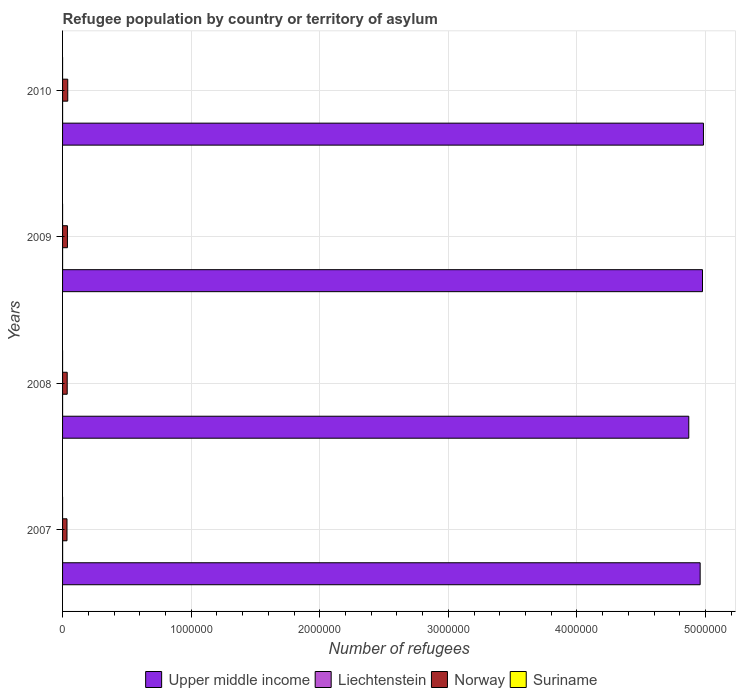How many different coloured bars are there?
Offer a very short reply. 4. What is the label of the 4th group of bars from the top?
Offer a terse response. 2007. What is the number of refugees in Liechtenstein in 2007?
Provide a succinct answer. 283. Across all years, what is the maximum number of refugees in Upper middle income?
Offer a very short reply. 4.98e+06. Across all years, what is the minimum number of refugees in Norway?
Your answer should be very brief. 3.45e+04. In which year was the number of refugees in Norway minimum?
Your answer should be very brief. 2007. What is the total number of refugees in Norway in the graph?
Provide a succinct answer. 1.49e+05. What is the difference between the number of refugees in Norway in 2007 and that in 2008?
Provide a short and direct response. -1579. What is the difference between the number of refugees in Upper middle income in 2008 and the number of refugees in Norway in 2007?
Keep it short and to the point. 4.84e+06. In the year 2007, what is the difference between the number of refugees in Norway and number of refugees in Liechtenstein?
Keep it short and to the point. 3.42e+04. What is the ratio of the number of refugees in Liechtenstein in 2009 to that in 2010?
Ensure brevity in your answer.  0.99. Is the number of refugees in Liechtenstein in 2007 less than that in 2009?
Make the answer very short. No. Is the difference between the number of refugees in Norway in 2008 and 2009 greater than the difference between the number of refugees in Liechtenstein in 2008 and 2009?
Provide a short and direct response. No. What is the difference between the highest and the second highest number of refugees in Upper middle income?
Give a very brief answer. 7314. What is the difference between the highest and the lowest number of refugees in Liechtenstein?
Your answer should be very brief. 194. Is the sum of the number of refugees in Suriname in 2007 and 2010 greater than the maximum number of refugees in Norway across all years?
Offer a very short reply. No. What does the 4th bar from the top in 2010 represents?
Provide a succinct answer. Upper middle income. Is it the case that in every year, the sum of the number of refugees in Suriname and number of refugees in Liechtenstein is greater than the number of refugees in Upper middle income?
Keep it short and to the point. No. What is the difference between two consecutive major ticks on the X-axis?
Provide a succinct answer. 1.00e+06. Does the graph contain any zero values?
Give a very brief answer. No. Where does the legend appear in the graph?
Offer a very short reply. Bottom center. How many legend labels are there?
Your answer should be very brief. 4. What is the title of the graph?
Your answer should be very brief. Refugee population by country or territory of asylum. Does "Venezuela" appear as one of the legend labels in the graph?
Ensure brevity in your answer.  No. What is the label or title of the X-axis?
Your response must be concise. Number of refugees. What is the Number of refugees in Upper middle income in 2007?
Give a very brief answer. 4.96e+06. What is the Number of refugees of Liechtenstein in 2007?
Provide a succinct answer. 283. What is the Number of refugees of Norway in 2007?
Your answer should be compact. 3.45e+04. What is the Number of refugees in Upper middle income in 2008?
Keep it short and to the point. 4.87e+06. What is the Number of refugees of Liechtenstein in 2008?
Give a very brief answer. 89. What is the Number of refugees in Norway in 2008?
Make the answer very short. 3.61e+04. What is the Number of refugees of Suriname in 2008?
Provide a short and direct response. 1. What is the Number of refugees in Upper middle income in 2009?
Keep it short and to the point. 4.98e+06. What is the Number of refugees in Liechtenstein in 2009?
Provide a succinct answer. 91. What is the Number of refugees in Norway in 2009?
Your answer should be compact. 3.78e+04. What is the Number of refugees of Upper middle income in 2010?
Ensure brevity in your answer.  4.98e+06. What is the Number of refugees in Liechtenstein in 2010?
Keep it short and to the point. 92. What is the Number of refugees in Norway in 2010?
Your response must be concise. 4.03e+04. Across all years, what is the maximum Number of refugees in Upper middle income?
Keep it short and to the point. 4.98e+06. Across all years, what is the maximum Number of refugees of Liechtenstein?
Your answer should be very brief. 283. Across all years, what is the maximum Number of refugees of Norway?
Keep it short and to the point. 4.03e+04. Across all years, what is the maximum Number of refugees of Suriname?
Ensure brevity in your answer.  1. Across all years, what is the minimum Number of refugees in Upper middle income?
Offer a very short reply. 4.87e+06. Across all years, what is the minimum Number of refugees in Liechtenstein?
Give a very brief answer. 89. Across all years, what is the minimum Number of refugees of Norway?
Ensure brevity in your answer.  3.45e+04. Across all years, what is the minimum Number of refugees in Suriname?
Make the answer very short. 1. What is the total Number of refugees in Upper middle income in the graph?
Provide a succinct answer. 1.98e+07. What is the total Number of refugees of Liechtenstein in the graph?
Offer a very short reply. 555. What is the total Number of refugees of Norway in the graph?
Your response must be concise. 1.49e+05. What is the difference between the Number of refugees in Upper middle income in 2007 and that in 2008?
Offer a terse response. 8.84e+04. What is the difference between the Number of refugees in Liechtenstein in 2007 and that in 2008?
Your answer should be very brief. 194. What is the difference between the Number of refugees in Norway in 2007 and that in 2008?
Your response must be concise. -1579. What is the difference between the Number of refugees in Suriname in 2007 and that in 2008?
Offer a very short reply. 0. What is the difference between the Number of refugees in Upper middle income in 2007 and that in 2009?
Give a very brief answer. -1.83e+04. What is the difference between the Number of refugees of Liechtenstein in 2007 and that in 2009?
Give a very brief answer. 192. What is the difference between the Number of refugees of Norway in 2007 and that in 2009?
Offer a terse response. -3304. What is the difference between the Number of refugees of Suriname in 2007 and that in 2009?
Ensure brevity in your answer.  0. What is the difference between the Number of refugees in Upper middle income in 2007 and that in 2010?
Your answer should be compact. -2.56e+04. What is the difference between the Number of refugees in Liechtenstein in 2007 and that in 2010?
Your answer should be compact. 191. What is the difference between the Number of refugees in Norway in 2007 and that in 2010?
Ensure brevity in your answer.  -5738. What is the difference between the Number of refugees in Upper middle income in 2008 and that in 2009?
Offer a terse response. -1.07e+05. What is the difference between the Number of refugees of Norway in 2008 and that in 2009?
Give a very brief answer. -1725. What is the difference between the Number of refugees in Upper middle income in 2008 and that in 2010?
Your answer should be very brief. -1.14e+05. What is the difference between the Number of refugees in Norway in 2008 and that in 2010?
Ensure brevity in your answer.  -4159. What is the difference between the Number of refugees of Suriname in 2008 and that in 2010?
Give a very brief answer. 0. What is the difference between the Number of refugees of Upper middle income in 2009 and that in 2010?
Your answer should be very brief. -7314. What is the difference between the Number of refugees of Norway in 2009 and that in 2010?
Make the answer very short. -2434. What is the difference between the Number of refugees of Suriname in 2009 and that in 2010?
Ensure brevity in your answer.  0. What is the difference between the Number of refugees in Upper middle income in 2007 and the Number of refugees in Liechtenstein in 2008?
Make the answer very short. 4.96e+06. What is the difference between the Number of refugees in Upper middle income in 2007 and the Number of refugees in Norway in 2008?
Offer a very short reply. 4.92e+06. What is the difference between the Number of refugees of Upper middle income in 2007 and the Number of refugees of Suriname in 2008?
Your answer should be very brief. 4.96e+06. What is the difference between the Number of refugees of Liechtenstein in 2007 and the Number of refugees of Norway in 2008?
Your answer should be very brief. -3.58e+04. What is the difference between the Number of refugees in Liechtenstein in 2007 and the Number of refugees in Suriname in 2008?
Ensure brevity in your answer.  282. What is the difference between the Number of refugees of Norway in 2007 and the Number of refugees of Suriname in 2008?
Your answer should be compact. 3.45e+04. What is the difference between the Number of refugees in Upper middle income in 2007 and the Number of refugees in Liechtenstein in 2009?
Your answer should be compact. 4.96e+06. What is the difference between the Number of refugees of Upper middle income in 2007 and the Number of refugees of Norway in 2009?
Your response must be concise. 4.92e+06. What is the difference between the Number of refugees in Upper middle income in 2007 and the Number of refugees in Suriname in 2009?
Offer a very short reply. 4.96e+06. What is the difference between the Number of refugees of Liechtenstein in 2007 and the Number of refugees of Norway in 2009?
Offer a terse response. -3.75e+04. What is the difference between the Number of refugees of Liechtenstein in 2007 and the Number of refugees of Suriname in 2009?
Provide a succinct answer. 282. What is the difference between the Number of refugees of Norway in 2007 and the Number of refugees of Suriname in 2009?
Your answer should be compact. 3.45e+04. What is the difference between the Number of refugees of Upper middle income in 2007 and the Number of refugees of Liechtenstein in 2010?
Your answer should be compact. 4.96e+06. What is the difference between the Number of refugees in Upper middle income in 2007 and the Number of refugees in Norway in 2010?
Provide a succinct answer. 4.92e+06. What is the difference between the Number of refugees of Upper middle income in 2007 and the Number of refugees of Suriname in 2010?
Your answer should be very brief. 4.96e+06. What is the difference between the Number of refugees in Liechtenstein in 2007 and the Number of refugees in Norway in 2010?
Ensure brevity in your answer.  -4.00e+04. What is the difference between the Number of refugees in Liechtenstein in 2007 and the Number of refugees in Suriname in 2010?
Your response must be concise. 282. What is the difference between the Number of refugees of Norway in 2007 and the Number of refugees of Suriname in 2010?
Offer a very short reply. 3.45e+04. What is the difference between the Number of refugees in Upper middle income in 2008 and the Number of refugees in Liechtenstein in 2009?
Offer a terse response. 4.87e+06. What is the difference between the Number of refugees of Upper middle income in 2008 and the Number of refugees of Norway in 2009?
Offer a terse response. 4.83e+06. What is the difference between the Number of refugees in Upper middle income in 2008 and the Number of refugees in Suriname in 2009?
Make the answer very short. 4.87e+06. What is the difference between the Number of refugees of Liechtenstein in 2008 and the Number of refugees of Norway in 2009?
Give a very brief answer. -3.77e+04. What is the difference between the Number of refugees in Norway in 2008 and the Number of refugees in Suriname in 2009?
Your answer should be very brief. 3.61e+04. What is the difference between the Number of refugees in Upper middle income in 2008 and the Number of refugees in Liechtenstein in 2010?
Make the answer very short. 4.87e+06. What is the difference between the Number of refugees in Upper middle income in 2008 and the Number of refugees in Norway in 2010?
Provide a short and direct response. 4.83e+06. What is the difference between the Number of refugees of Upper middle income in 2008 and the Number of refugees of Suriname in 2010?
Keep it short and to the point. 4.87e+06. What is the difference between the Number of refugees of Liechtenstein in 2008 and the Number of refugees of Norway in 2010?
Provide a succinct answer. -4.02e+04. What is the difference between the Number of refugees in Norway in 2008 and the Number of refugees in Suriname in 2010?
Make the answer very short. 3.61e+04. What is the difference between the Number of refugees of Upper middle income in 2009 and the Number of refugees of Liechtenstein in 2010?
Offer a terse response. 4.98e+06. What is the difference between the Number of refugees in Upper middle income in 2009 and the Number of refugees in Norway in 2010?
Offer a terse response. 4.94e+06. What is the difference between the Number of refugees of Upper middle income in 2009 and the Number of refugees of Suriname in 2010?
Provide a succinct answer. 4.98e+06. What is the difference between the Number of refugees in Liechtenstein in 2009 and the Number of refugees in Norway in 2010?
Make the answer very short. -4.02e+04. What is the difference between the Number of refugees in Liechtenstein in 2009 and the Number of refugees in Suriname in 2010?
Ensure brevity in your answer.  90. What is the difference between the Number of refugees in Norway in 2009 and the Number of refugees in Suriname in 2010?
Keep it short and to the point. 3.78e+04. What is the average Number of refugees in Upper middle income per year?
Give a very brief answer. 4.95e+06. What is the average Number of refugees in Liechtenstein per year?
Make the answer very short. 138.75. What is the average Number of refugees of Norway per year?
Offer a very short reply. 3.72e+04. In the year 2007, what is the difference between the Number of refugees in Upper middle income and Number of refugees in Liechtenstein?
Provide a short and direct response. 4.96e+06. In the year 2007, what is the difference between the Number of refugees of Upper middle income and Number of refugees of Norway?
Your response must be concise. 4.92e+06. In the year 2007, what is the difference between the Number of refugees of Upper middle income and Number of refugees of Suriname?
Keep it short and to the point. 4.96e+06. In the year 2007, what is the difference between the Number of refugees in Liechtenstein and Number of refugees in Norway?
Your response must be concise. -3.42e+04. In the year 2007, what is the difference between the Number of refugees of Liechtenstein and Number of refugees of Suriname?
Keep it short and to the point. 282. In the year 2007, what is the difference between the Number of refugees of Norway and Number of refugees of Suriname?
Provide a succinct answer. 3.45e+04. In the year 2008, what is the difference between the Number of refugees in Upper middle income and Number of refugees in Liechtenstein?
Offer a terse response. 4.87e+06. In the year 2008, what is the difference between the Number of refugees of Upper middle income and Number of refugees of Norway?
Your response must be concise. 4.83e+06. In the year 2008, what is the difference between the Number of refugees of Upper middle income and Number of refugees of Suriname?
Offer a terse response. 4.87e+06. In the year 2008, what is the difference between the Number of refugees of Liechtenstein and Number of refugees of Norway?
Offer a very short reply. -3.60e+04. In the year 2008, what is the difference between the Number of refugees in Norway and Number of refugees in Suriname?
Your answer should be compact. 3.61e+04. In the year 2009, what is the difference between the Number of refugees in Upper middle income and Number of refugees in Liechtenstein?
Offer a very short reply. 4.98e+06. In the year 2009, what is the difference between the Number of refugees of Upper middle income and Number of refugees of Norway?
Your answer should be very brief. 4.94e+06. In the year 2009, what is the difference between the Number of refugees of Upper middle income and Number of refugees of Suriname?
Keep it short and to the point. 4.98e+06. In the year 2009, what is the difference between the Number of refugees in Liechtenstein and Number of refugees in Norway?
Give a very brief answer. -3.77e+04. In the year 2009, what is the difference between the Number of refugees of Norway and Number of refugees of Suriname?
Provide a short and direct response. 3.78e+04. In the year 2010, what is the difference between the Number of refugees of Upper middle income and Number of refugees of Liechtenstein?
Ensure brevity in your answer.  4.98e+06. In the year 2010, what is the difference between the Number of refugees in Upper middle income and Number of refugees in Norway?
Your answer should be very brief. 4.94e+06. In the year 2010, what is the difference between the Number of refugees in Upper middle income and Number of refugees in Suriname?
Offer a very short reply. 4.98e+06. In the year 2010, what is the difference between the Number of refugees in Liechtenstein and Number of refugees in Norway?
Your response must be concise. -4.02e+04. In the year 2010, what is the difference between the Number of refugees of Liechtenstein and Number of refugees of Suriname?
Your answer should be very brief. 91. In the year 2010, what is the difference between the Number of refugees in Norway and Number of refugees in Suriname?
Make the answer very short. 4.03e+04. What is the ratio of the Number of refugees of Upper middle income in 2007 to that in 2008?
Provide a short and direct response. 1.02. What is the ratio of the Number of refugees in Liechtenstein in 2007 to that in 2008?
Keep it short and to the point. 3.18. What is the ratio of the Number of refugees of Norway in 2007 to that in 2008?
Make the answer very short. 0.96. What is the ratio of the Number of refugees in Suriname in 2007 to that in 2008?
Give a very brief answer. 1. What is the ratio of the Number of refugees in Upper middle income in 2007 to that in 2009?
Make the answer very short. 1. What is the ratio of the Number of refugees in Liechtenstein in 2007 to that in 2009?
Give a very brief answer. 3.11. What is the ratio of the Number of refugees in Norway in 2007 to that in 2009?
Offer a very short reply. 0.91. What is the ratio of the Number of refugees of Suriname in 2007 to that in 2009?
Your answer should be compact. 1. What is the ratio of the Number of refugees of Liechtenstein in 2007 to that in 2010?
Ensure brevity in your answer.  3.08. What is the ratio of the Number of refugees in Norway in 2007 to that in 2010?
Provide a succinct answer. 0.86. What is the ratio of the Number of refugees in Suriname in 2007 to that in 2010?
Your response must be concise. 1. What is the ratio of the Number of refugees of Upper middle income in 2008 to that in 2009?
Your answer should be compact. 0.98. What is the ratio of the Number of refugees in Liechtenstein in 2008 to that in 2009?
Your answer should be compact. 0.98. What is the ratio of the Number of refugees in Norway in 2008 to that in 2009?
Ensure brevity in your answer.  0.95. What is the ratio of the Number of refugees of Upper middle income in 2008 to that in 2010?
Ensure brevity in your answer.  0.98. What is the ratio of the Number of refugees in Liechtenstein in 2008 to that in 2010?
Provide a short and direct response. 0.97. What is the ratio of the Number of refugees of Norway in 2008 to that in 2010?
Make the answer very short. 0.9. What is the ratio of the Number of refugees in Upper middle income in 2009 to that in 2010?
Your answer should be very brief. 1. What is the ratio of the Number of refugees in Liechtenstein in 2009 to that in 2010?
Keep it short and to the point. 0.99. What is the ratio of the Number of refugees of Norway in 2009 to that in 2010?
Keep it short and to the point. 0.94. What is the ratio of the Number of refugees of Suriname in 2009 to that in 2010?
Your response must be concise. 1. What is the difference between the highest and the second highest Number of refugees in Upper middle income?
Your answer should be compact. 7314. What is the difference between the highest and the second highest Number of refugees in Liechtenstein?
Your response must be concise. 191. What is the difference between the highest and the second highest Number of refugees of Norway?
Make the answer very short. 2434. What is the difference between the highest and the lowest Number of refugees in Upper middle income?
Keep it short and to the point. 1.14e+05. What is the difference between the highest and the lowest Number of refugees of Liechtenstein?
Make the answer very short. 194. What is the difference between the highest and the lowest Number of refugees of Norway?
Provide a succinct answer. 5738. 